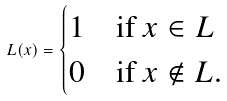<formula> <loc_0><loc_0><loc_500><loc_500>L ( x ) = \begin{cases} 1 & \text {if } x \in L \\ 0 & \text {if } x \not \in L . \end{cases}</formula> 